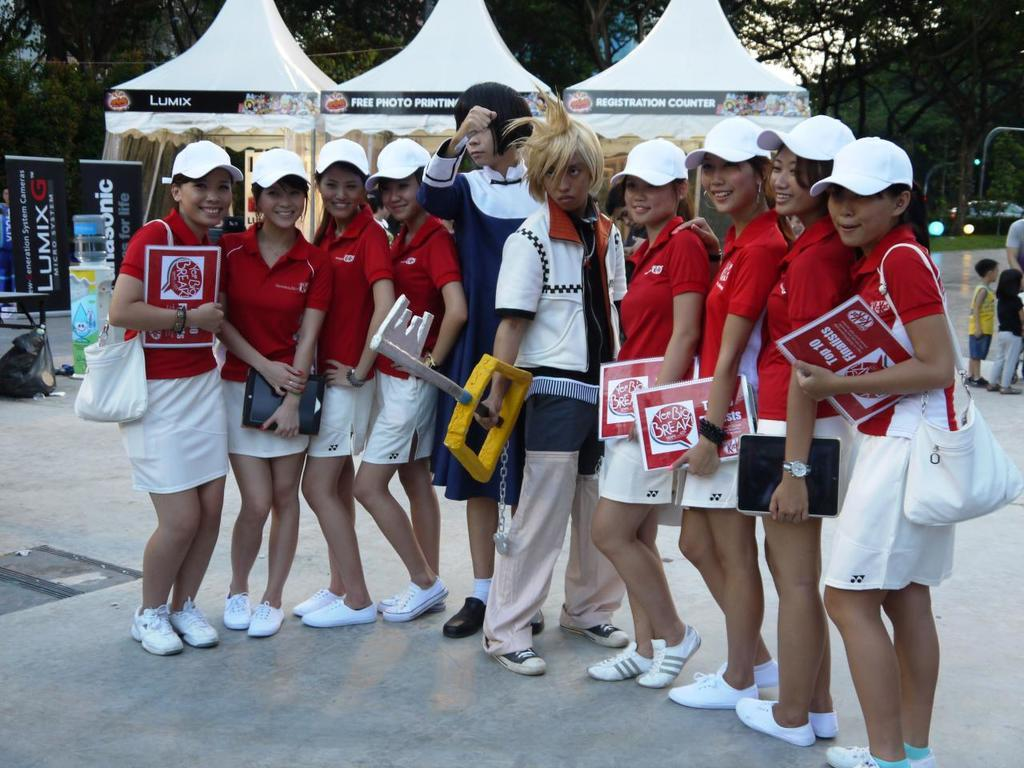<image>
Offer a succinct explanation of the picture presented. A group of women in matching outfits stands around two anime characters as they hold paper identifying them as top ten finalists. 